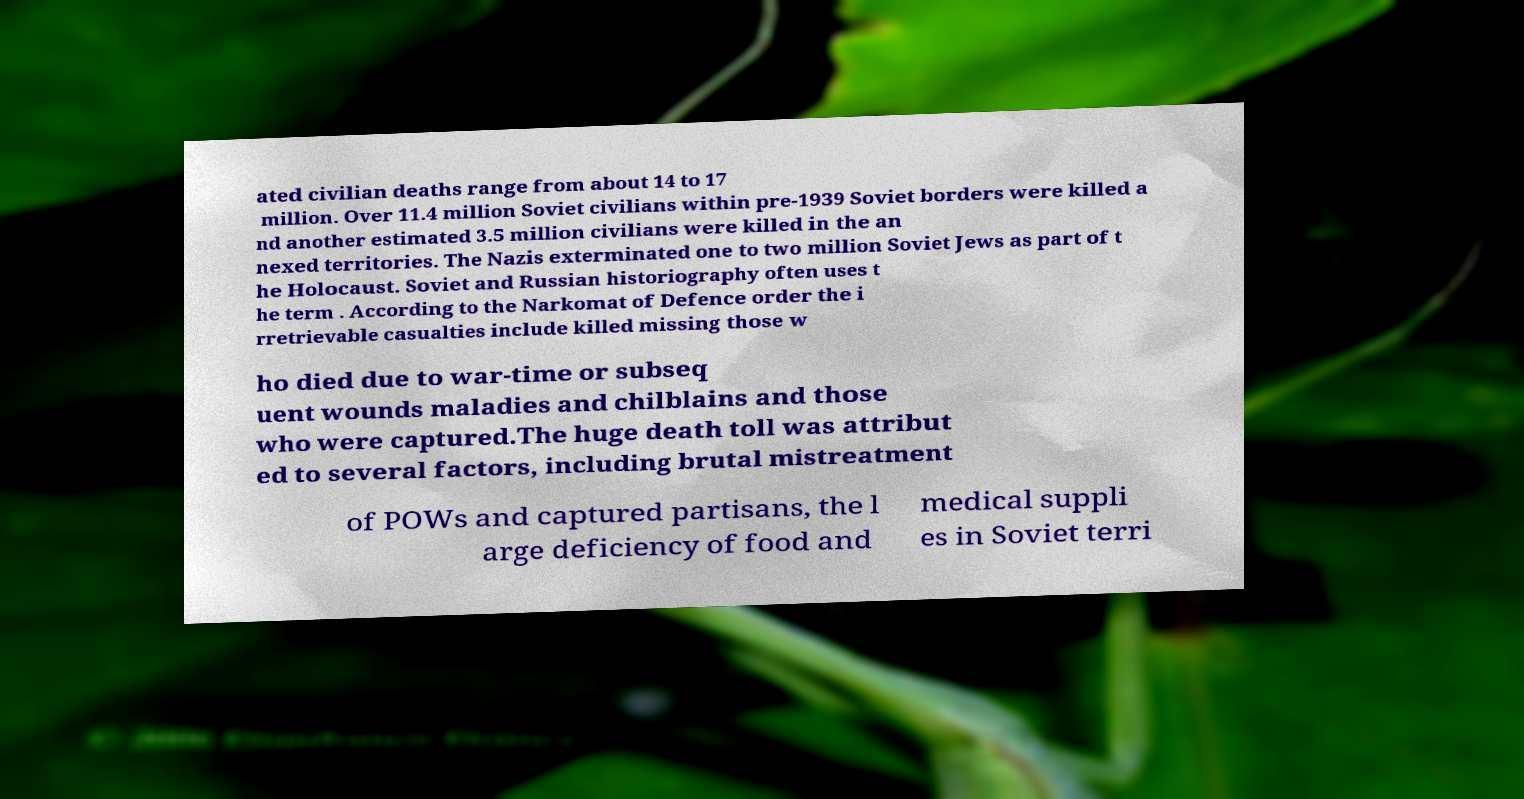Can you read and provide the text displayed in the image?This photo seems to have some interesting text. Can you extract and type it out for me? ated civilian deaths range from about 14 to 17 million. Over 11.4 million Soviet civilians within pre-1939 Soviet borders were killed a nd another estimated 3.5 million civilians were killed in the an nexed territories. The Nazis exterminated one to two million Soviet Jews as part of t he Holocaust. Soviet and Russian historiography often uses t he term . According to the Narkomat of Defence order the i rretrievable casualties include killed missing those w ho died due to war-time or subseq uent wounds maladies and chilblains and those who were captured.The huge death toll was attribut ed to several factors, including brutal mistreatment of POWs and captured partisans, the l arge deficiency of food and medical suppli es in Soviet terri 